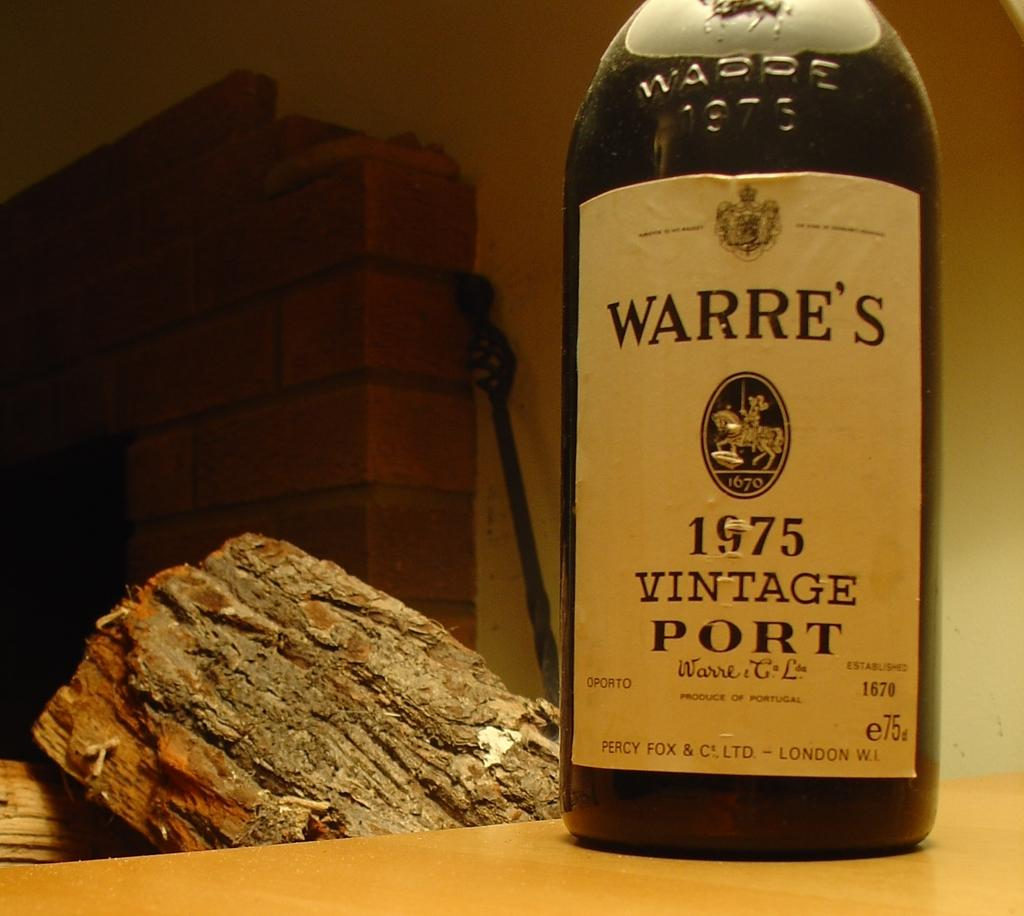<image>
Summarize the visual content of the image. the word warre's on a wine bottle next to a log 